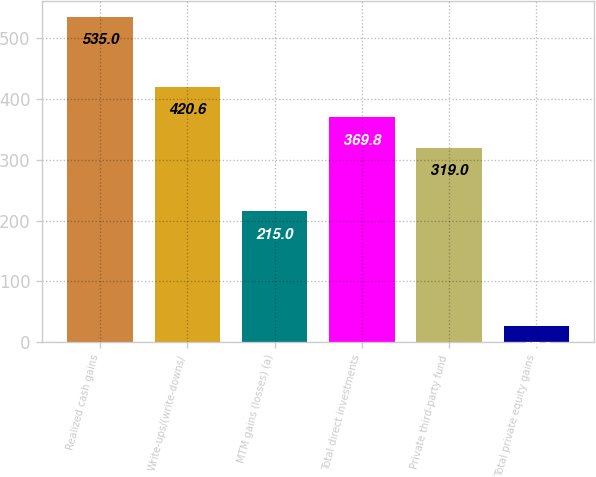Convert chart to OTSL. <chart><loc_0><loc_0><loc_500><loc_500><bar_chart><fcel>Realized cash gains<fcel>Write-ups/(write-downs/<fcel>MTM gains (losses) (a)<fcel>Total direct investments<fcel>Private third-party fund<fcel>Total private equity gains<nl><fcel>535<fcel>420.6<fcel>215<fcel>369.8<fcel>319<fcel>27<nl></chart> 